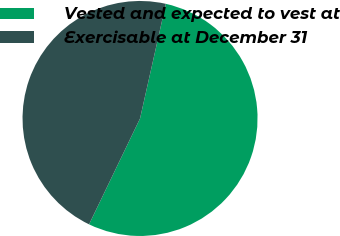Convert chart. <chart><loc_0><loc_0><loc_500><loc_500><pie_chart><fcel>Vested and expected to vest at<fcel>Exercisable at December 31<nl><fcel>53.62%<fcel>46.38%<nl></chart> 